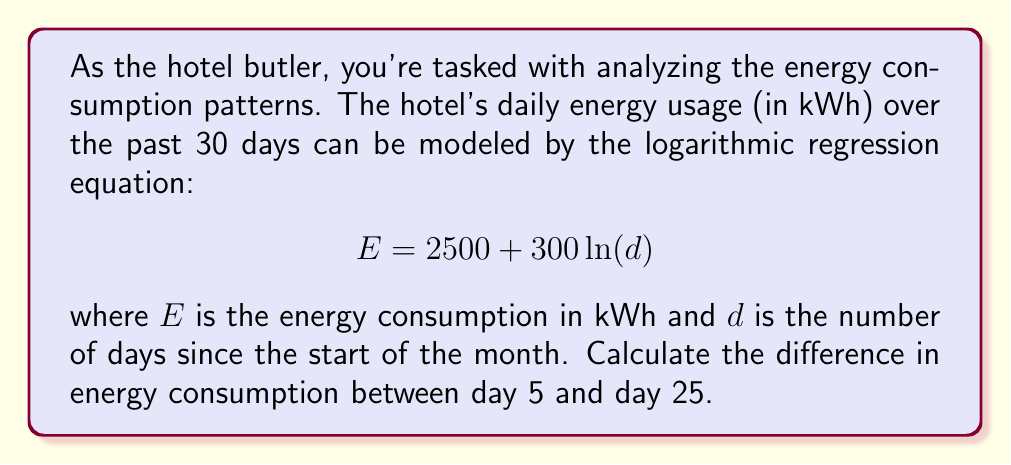Give your solution to this math problem. To solve this problem, we'll follow these steps:

1. Calculate the energy consumption on day 5:
   $$E_5 = 2500 + 300 \ln(5)$$
   $$E_5 = 2500 + 300 \cdot 1.6094$$
   $$E_5 = 2500 + 482.82$$
   $$E_5 = 2982.82 \text{ kWh}$$

2. Calculate the energy consumption on day 25:
   $$E_{25} = 2500 + 300 \ln(25)$$
   $$E_{25} = 2500 + 300 \cdot 3.2189$$
   $$E_{25} = 2500 + 965.67$$
   $$E_{25} = 3465.67 \text{ kWh}$$

3. Calculate the difference in energy consumption:
   $$\Delta E = E_{25} - E_5$$
   $$\Delta E = 3465.67 - 2982.82$$
   $$\Delta E = 482.85 \text{ kWh}$$
Answer: 482.85 kWh 